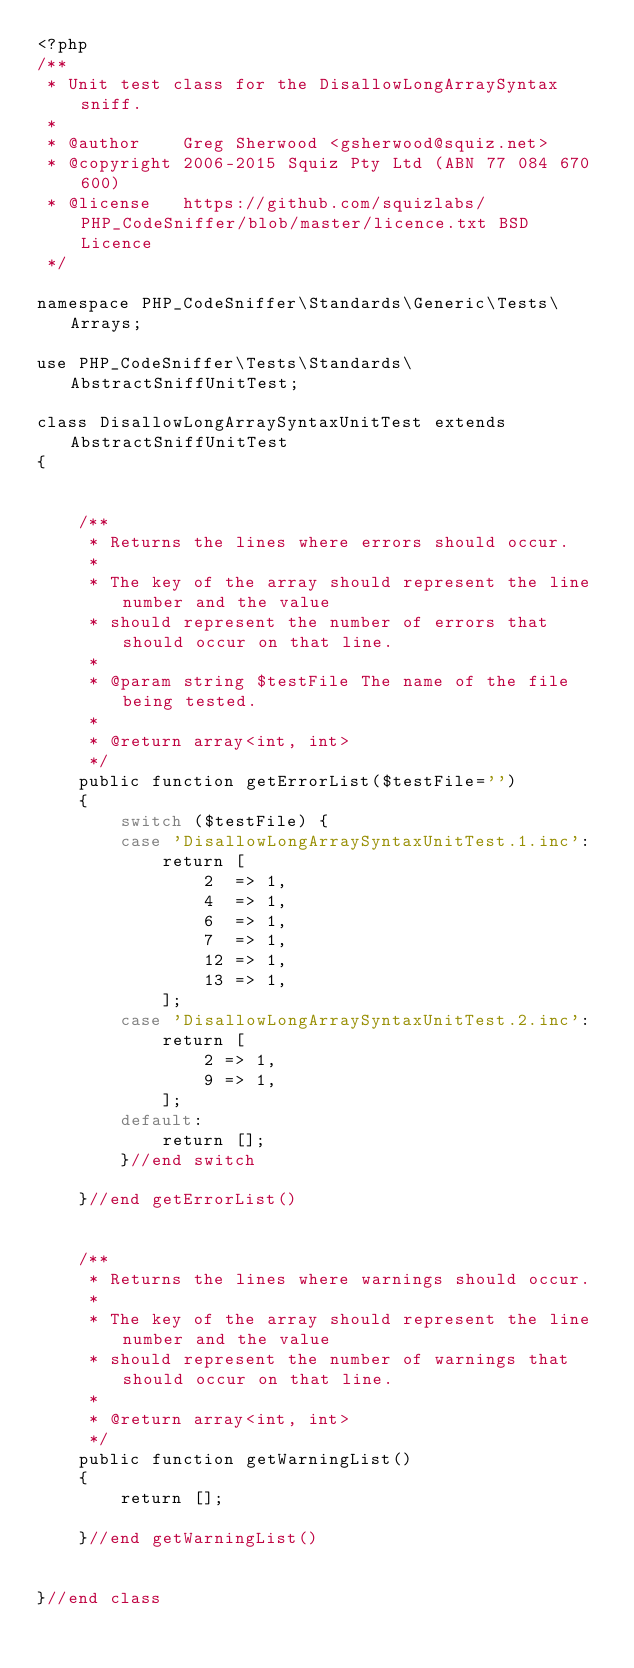<code> <loc_0><loc_0><loc_500><loc_500><_PHP_><?php
/**
 * Unit test class for the DisallowLongArraySyntax sniff.
 *
 * @author    Greg Sherwood <gsherwood@squiz.net>
 * @copyright 2006-2015 Squiz Pty Ltd (ABN 77 084 670 600)
 * @license   https://github.com/squizlabs/PHP_CodeSniffer/blob/master/licence.txt BSD Licence
 */

namespace PHP_CodeSniffer\Standards\Generic\Tests\Arrays;

use PHP_CodeSniffer\Tests\Standards\AbstractSniffUnitTest;

class DisallowLongArraySyntaxUnitTest extends AbstractSniffUnitTest
{


    /**
     * Returns the lines where errors should occur.
     *
     * The key of the array should represent the line number and the value
     * should represent the number of errors that should occur on that line.
     *
     * @param string $testFile The name of the file being tested.
     *
     * @return array<int, int>
     */
    public function getErrorList($testFile='')
    {
        switch ($testFile) {
        case 'DisallowLongArraySyntaxUnitTest.1.inc':
            return [
                2  => 1,
                4  => 1,
                6  => 1,
                7  => 1,
                12 => 1,
                13 => 1,
            ];
        case 'DisallowLongArraySyntaxUnitTest.2.inc':
            return [
                2 => 1,
                9 => 1,
            ];
        default:
            return [];
        }//end switch

    }//end getErrorList()


    /**
     * Returns the lines where warnings should occur.
     *
     * The key of the array should represent the line number and the value
     * should represent the number of warnings that should occur on that line.
     *
     * @return array<int, int>
     */
    public function getWarningList()
    {
        return [];

    }//end getWarningList()


}//end class
</code> 